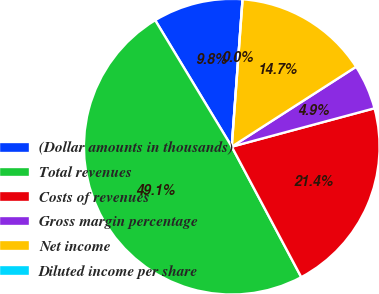Convert chart. <chart><loc_0><loc_0><loc_500><loc_500><pie_chart><fcel>(Dollar amounts in thousands)<fcel>Total revenues<fcel>Costs of revenues<fcel>Gross margin percentage<fcel>Net income<fcel>Diluted income per share<nl><fcel>9.83%<fcel>49.13%<fcel>21.39%<fcel>4.91%<fcel>14.74%<fcel>0.0%<nl></chart> 